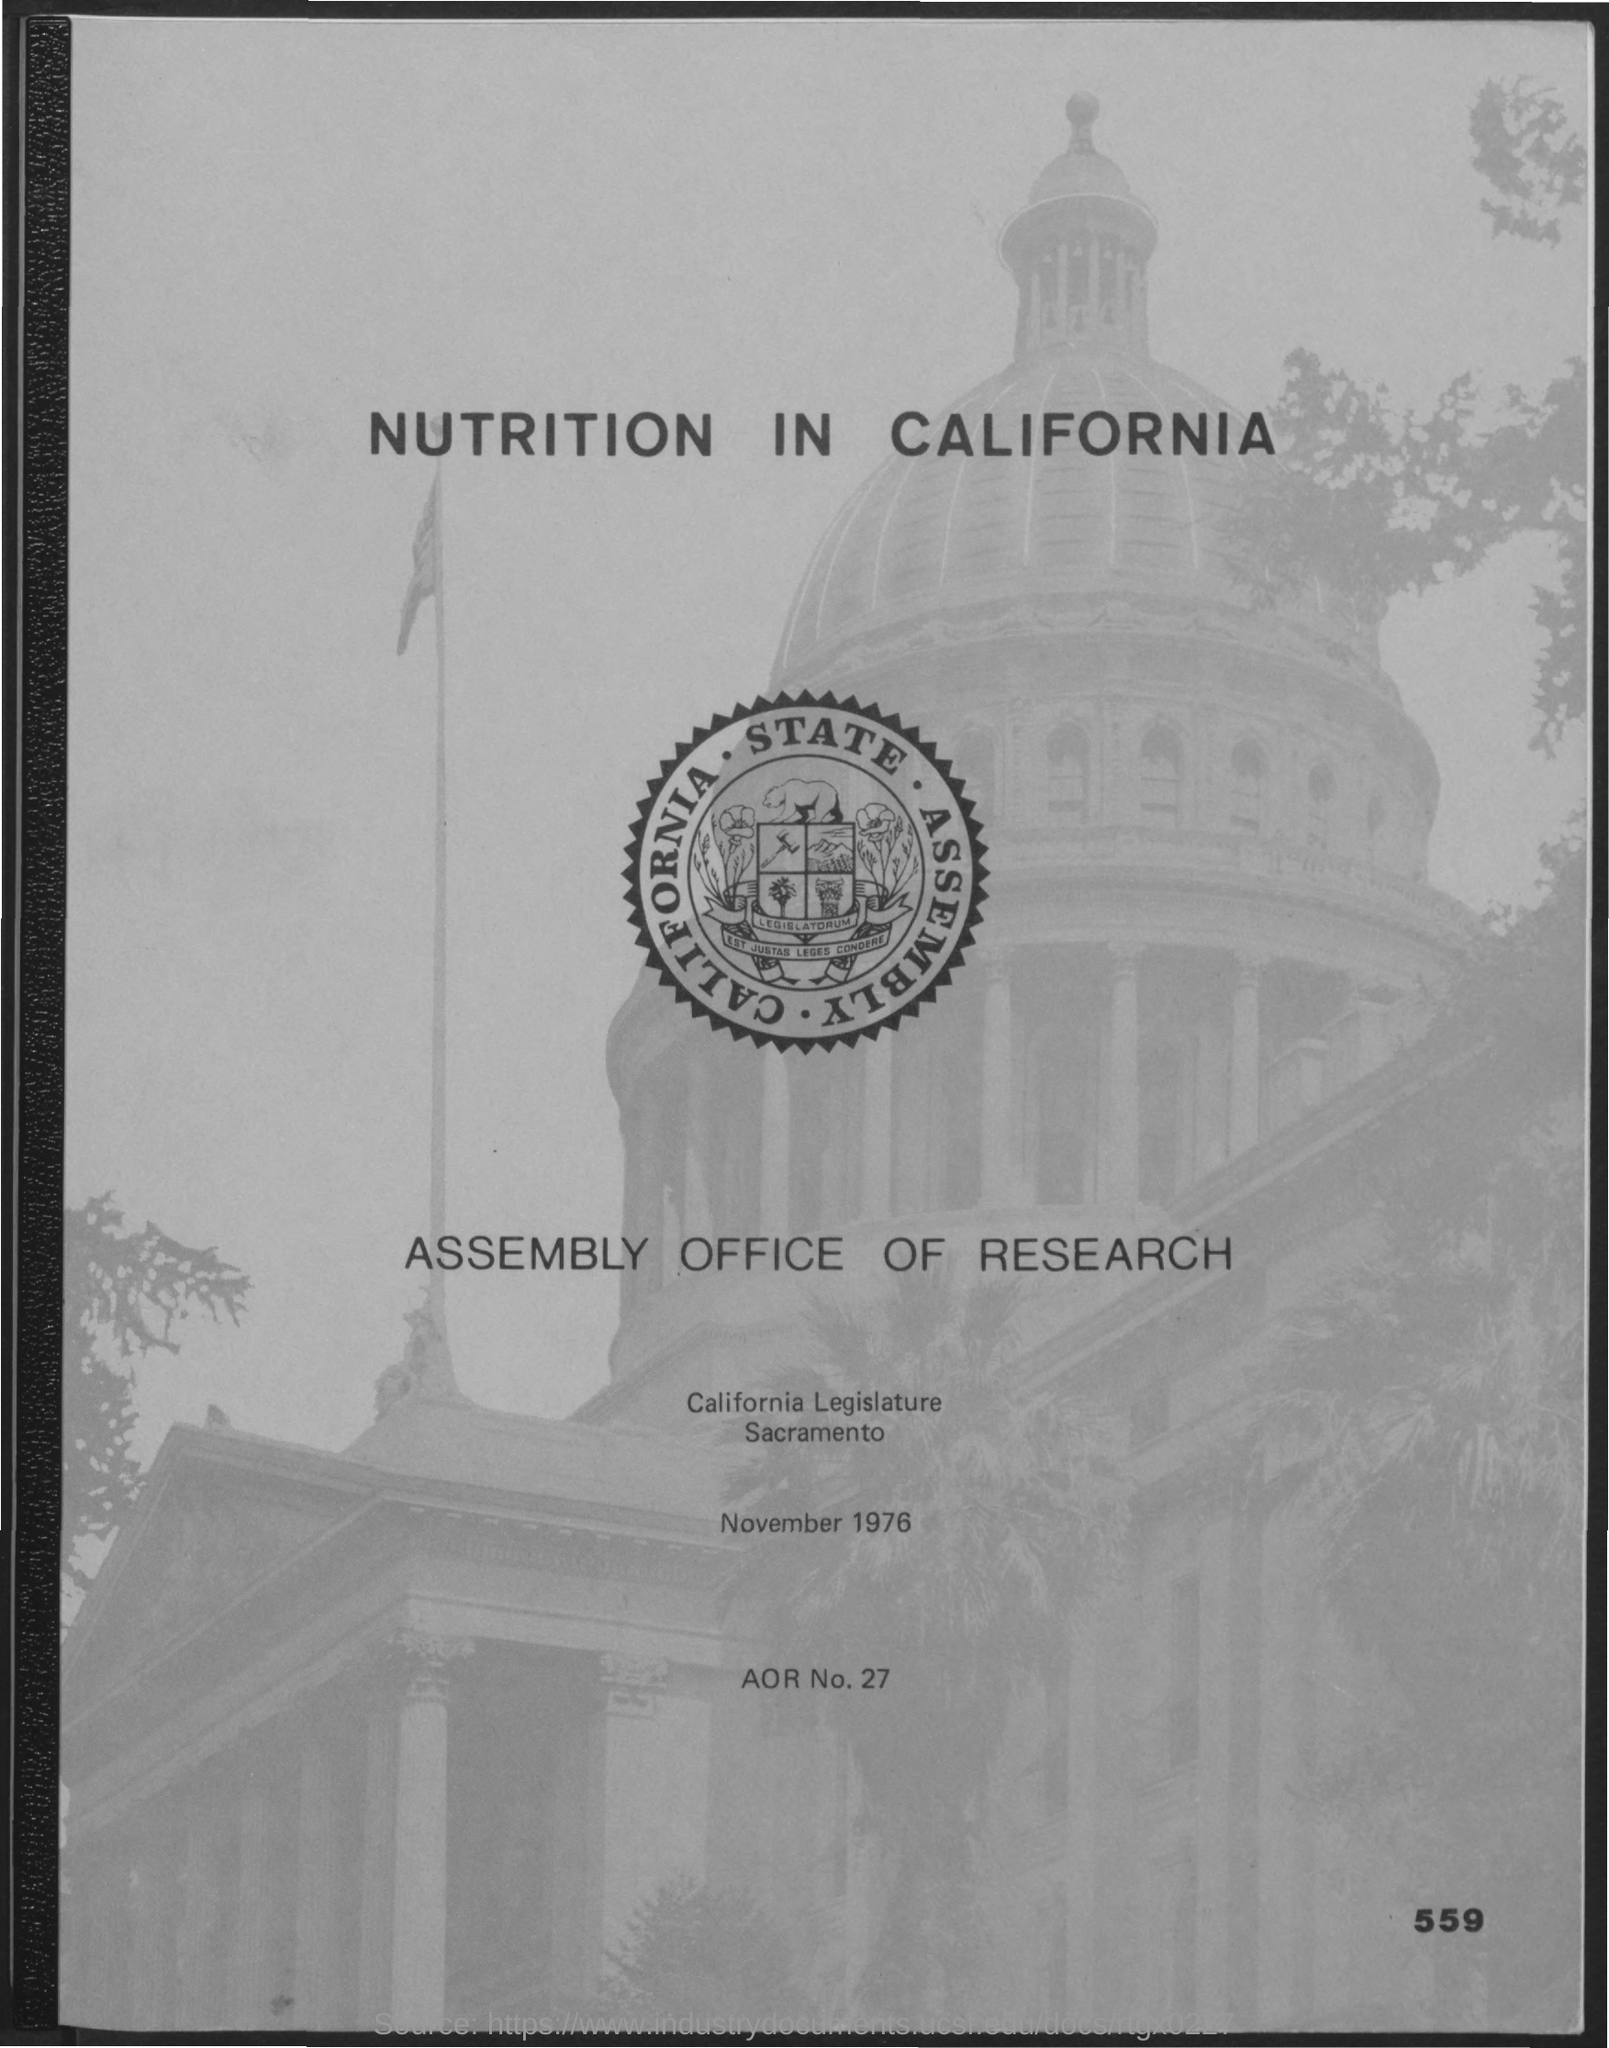Outline some significant characteristics in this image. What is the AOR number mentioned in the given page? It is 27... The date mentioned in the given page is November 1976. 